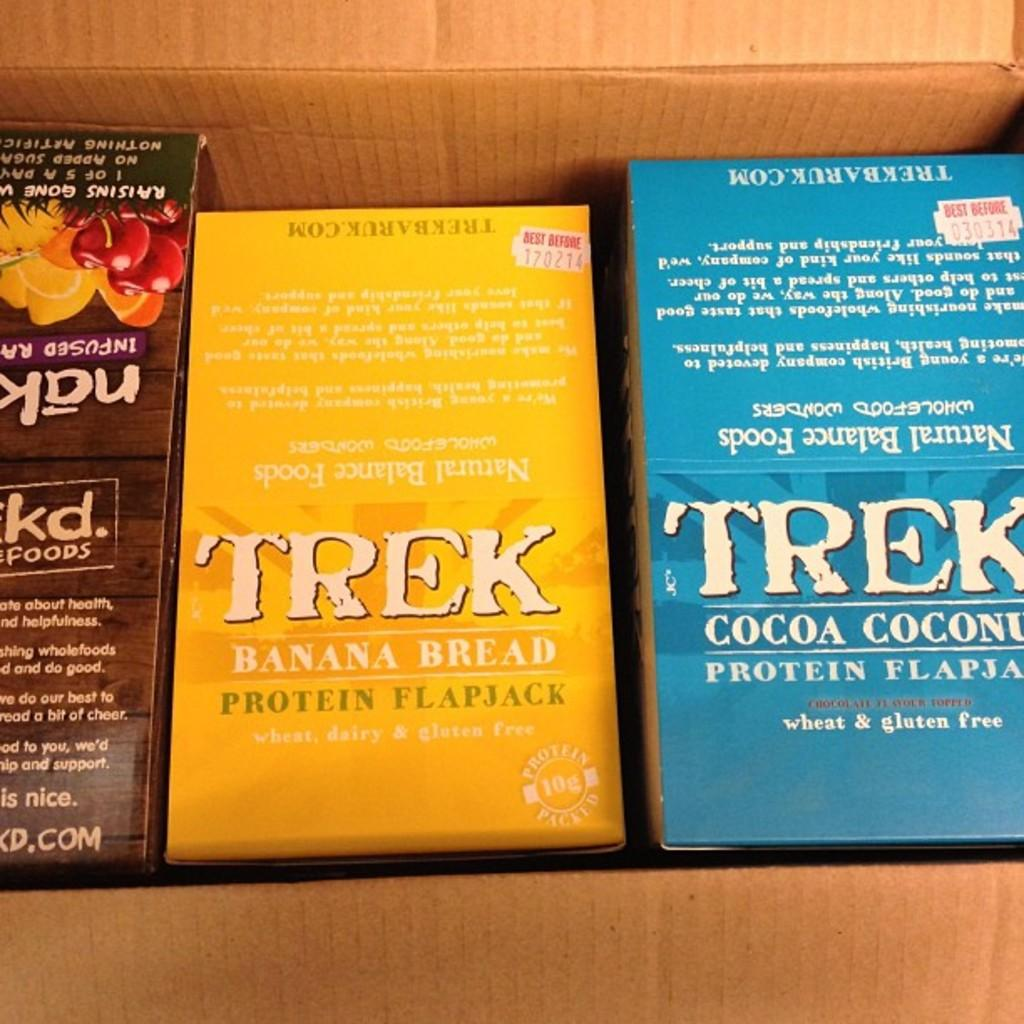<image>
Relay a brief, clear account of the picture shown. A cardboard box contains 3 products including TREK Banana Bread and Cocoa Coconut flavored Protein flapjacks. 